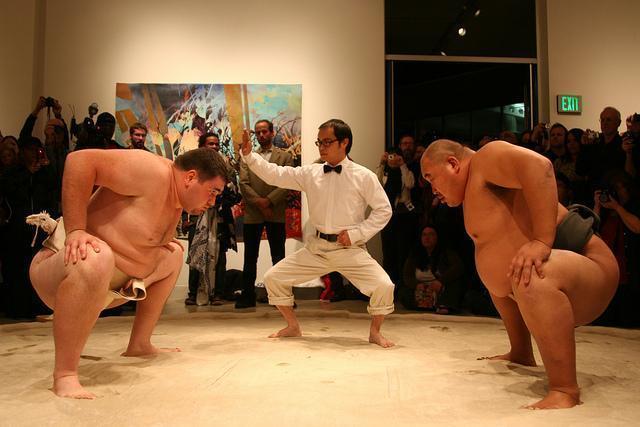This activity is most associated with which people group?
Select the accurate answer and provide justification: `Answer: choice
Rationale: srationale.`
Options: Tibetans, tanzanians, japanese, inuit. Answer: japanese.
Rationale: The men are participating in sumo wrestling. i did an internet search for the county of origin of sumo wrestling. 